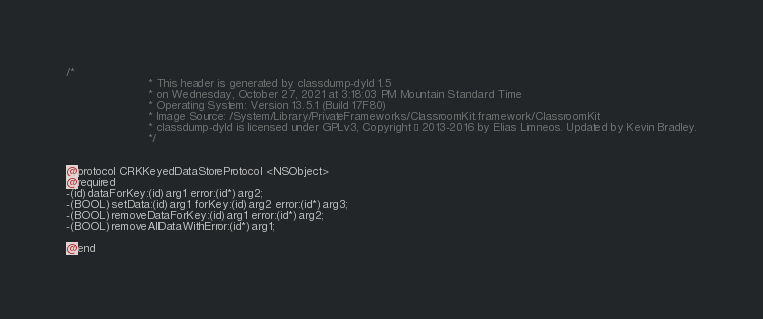Convert code to text. <code><loc_0><loc_0><loc_500><loc_500><_C_>/*
                       * This header is generated by classdump-dyld 1.5
                       * on Wednesday, October 27, 2021 at 3:18:03 PM Mountain Standard Time
                       * Operating System: Version 13.5.1 (Build 17F80)
                       * Image Source: /System/Library/PrivateFrameworks/ClassroomKit.framework/ClassroomKit
                       * classdump-dyld is licensed under GPLv3, Copyright © 2013-2016 by Elias Limneos. Updated by Kevin Bradley.
                       */


@protocol CRKKeyedDataStoreProtocol <NSObject>
@required
-(id)dataForKey:(id)arg1 error:(id*)arg2;
-(BOOL)setData:(id)arg1 forKey:(id)arg2 error:(id*)arg3;
-(BOOL)removeDataForKey:(id)arg1 error:(id*)arg2;
-(BOOL)removeAllDataWithError:(id*)arg1;

@end

</code> 